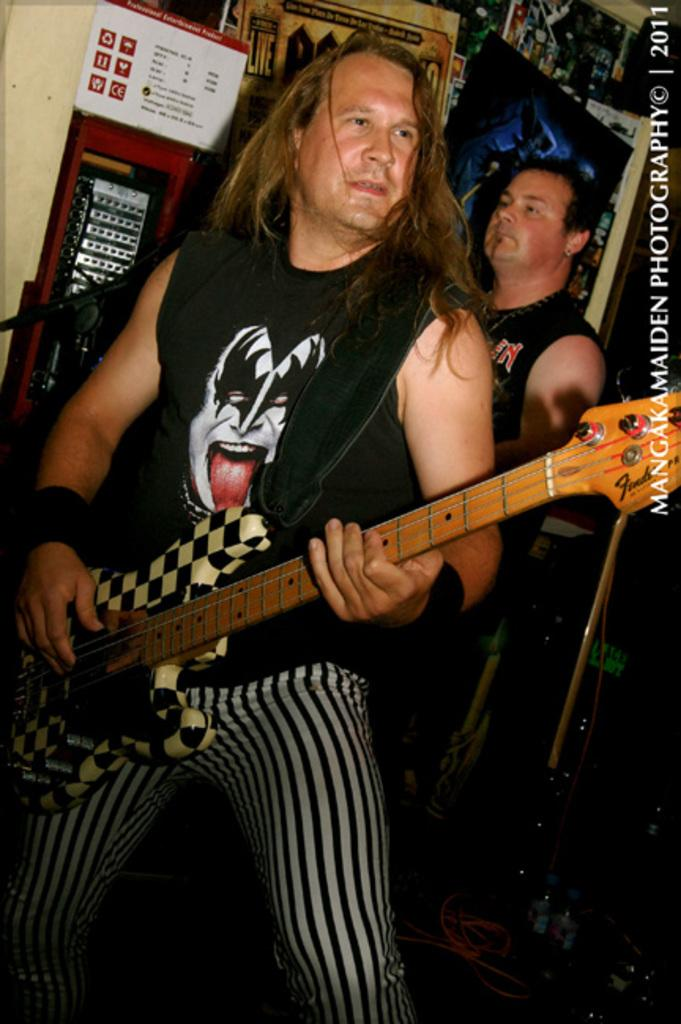How many people are in the image? There are two men in the image. What is one of the men holding? One of the men is holding a guitar. What is the man with the guitar doing? The man with the guitar is playing it. What can be seen in the background of the image? There are posters, a wall, and a microphone in the background of the image. What is the price of the soda being sold at the event in the image? There is no soda or event mentioned in the image; it features two men, one of whom is playing a guitar. Can you tell me the color of the curtain behind the microphone in the image? There is no curtain visible in the image; only posters, a wall, and a microphone are present in the background. 